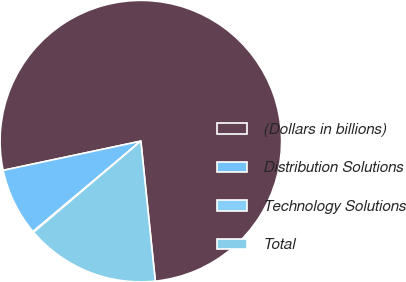<chart> <loc_0><loc_0><loc_500><loc_500><pie_chart><fcel>(Dollars in billions)<fcel>Distribution Solutions<fcel>Technology Solutions<fcel>Total<nl><fcel>76.69%<fcel>7.77%<fcel>0.11%<fcel>15.43%<nl></chart> 